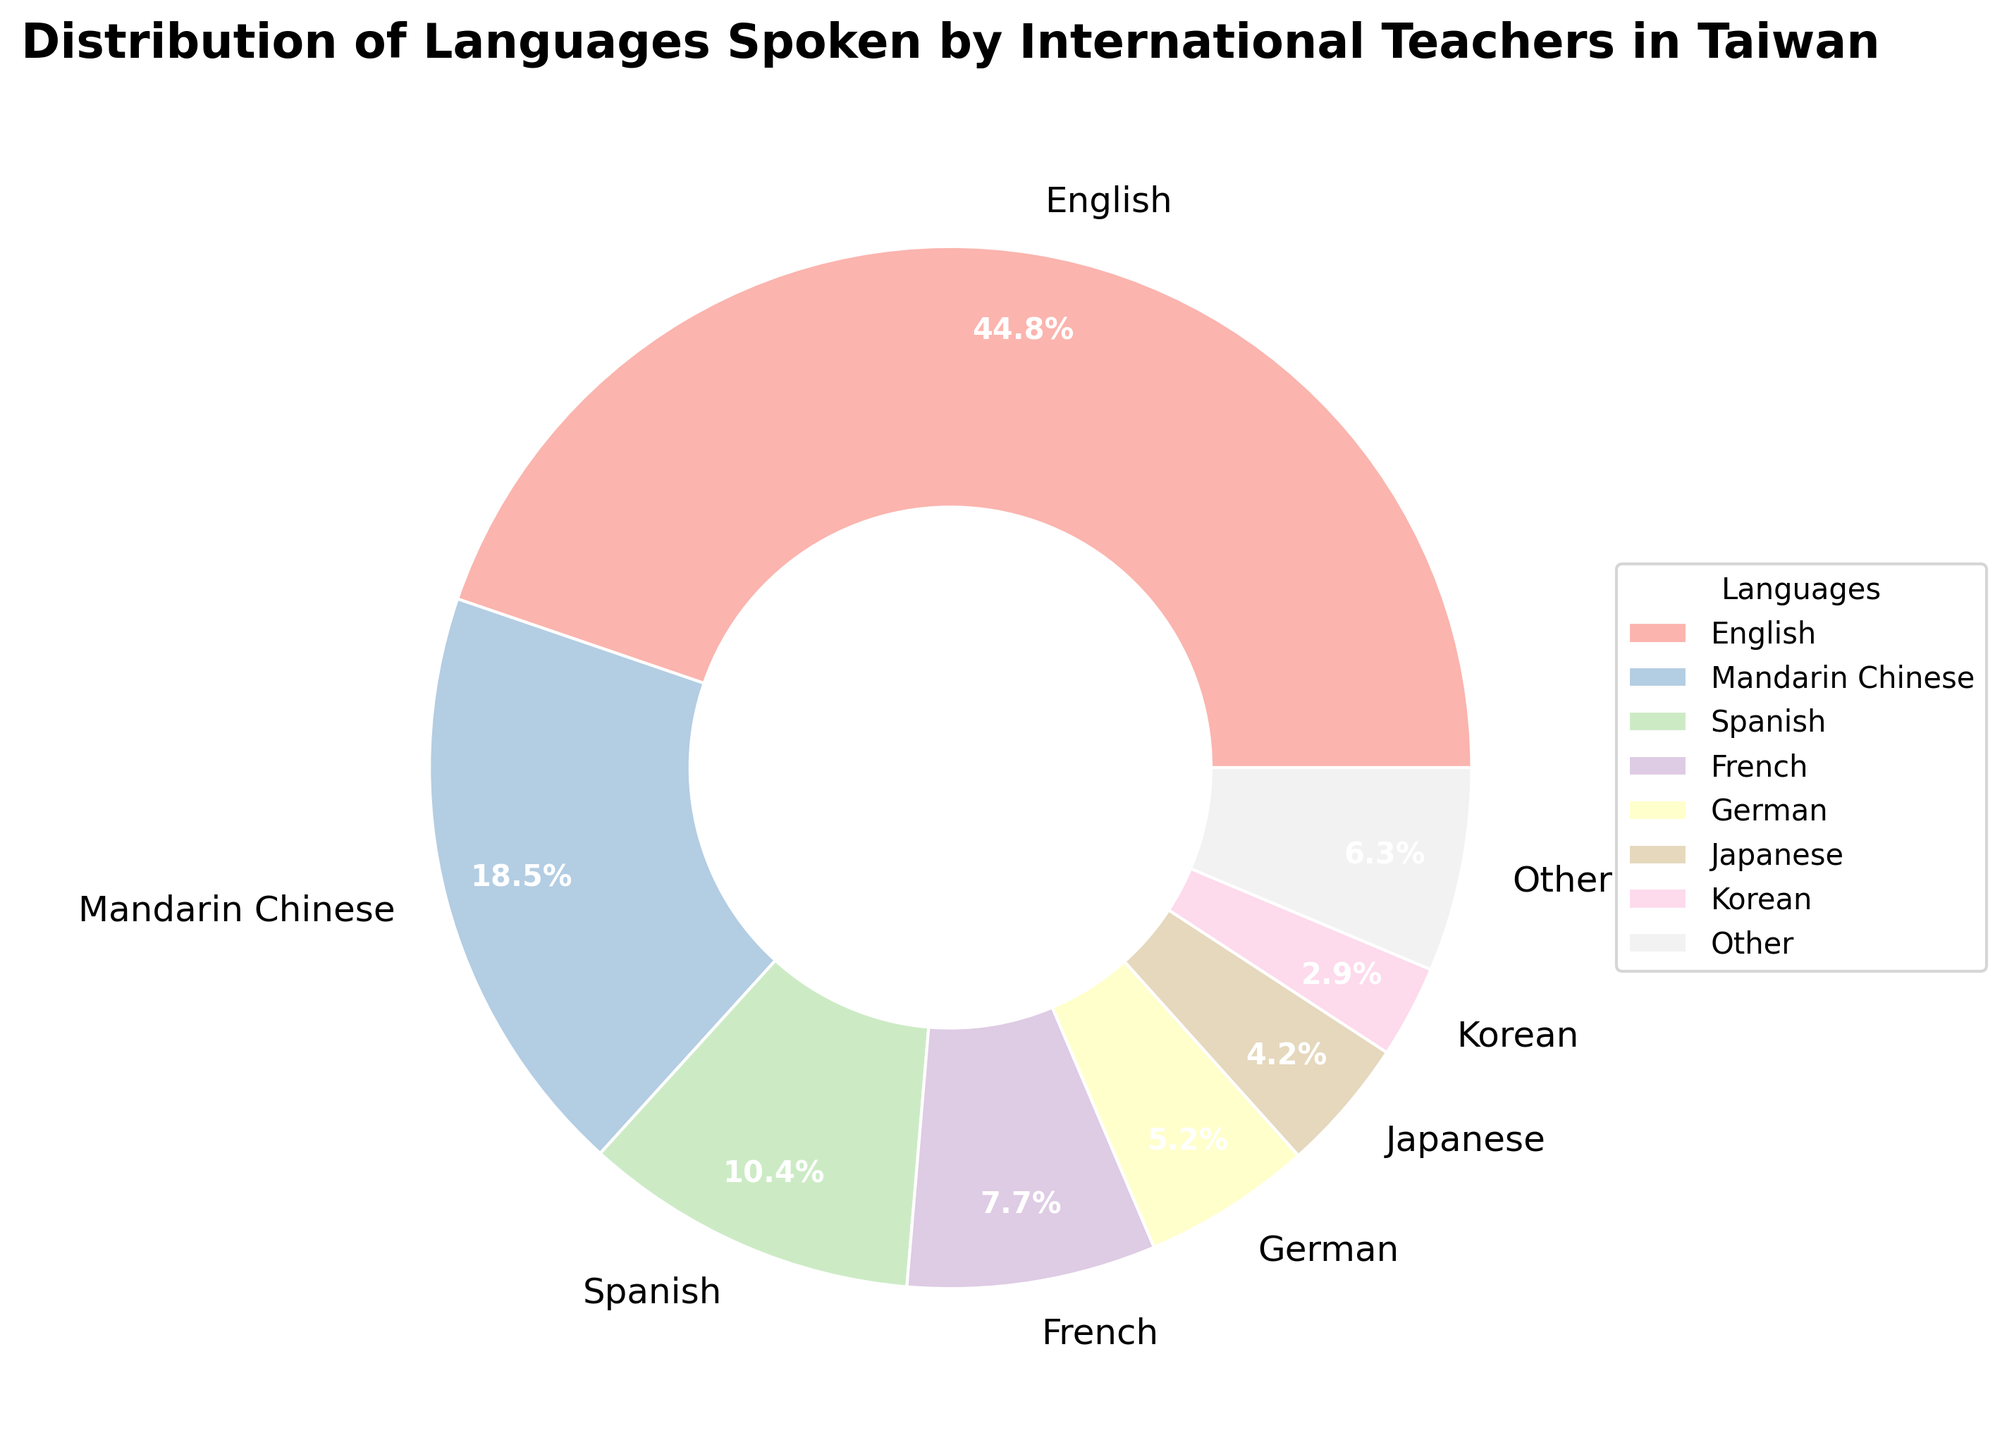What's the language spoken by the largest percentage of international teachers? By looking at the pie chart, the segment with the highest percentage is labeled "English", indicating that it is spoken by the largest percentage of international teachers.
Answer: English What's the difference in percentage between Mandarin Chinese speakers and Spanish speakers? From the chart, Mandarin Chinese speakers represent 18.7% and Spanish speakers represent 10.5%. The difference is found by subtracting these values: 18.7% - 10.5% = 8.2%.
Answer: 8.2% What is the combined percentage of teachers who speak French, German, and Japanese? According to the pie chart, the percentages for French, German, and Japanese are 7.8%, 5.3%, and 4.2% respectively. Summing these values gives: 7.8% + 5.3% + 4.2% = 17.3%.
Answer: 17.3% Compared to the languages categorized as "Other", is the percentage of Mandarin Chinese speakers higher or lower? The pie chart includes a segment labeled "Other" which is a combination of languages with individual percentages below the threshold. Since "Other" contains a percentage lower than 2.0%, and Mandarin Chinese is 18.7%, Mandarin Chinese's percentage is higher.
Answer: Higher Which language group is represented by the lightest color in the pie chart? By observing the visual coloring of the segments, the lightest color is usually associated with "Other" categories or smaller groups. Here, the "Other" category, which includes grouped smaller languages, is represented by the lightest color.
Answer: Other How many languages are categorized under 'Other'? Observing the pie chart and the data provided, languages with percentages below the threshold (2.0%) are grouped under "Other". These languages are Russian, Italian, Dutch, Portuguese, Hindi, and Arabic, making a total of 6 languages.
Answer: 6 Which two language groups have the closest percentages, and what are their percentages? From the chart, Japanese and Korean have the closest percentages, which are 4.2% and 2.9% respectively.
Answer: Japanese (4.2%) and Korean (2.9%) What is the sum of percentages of all languages that are explicitly labeled in the pie chart, excluding "Other"? To find this, sum all explicitly labeled languages' percentages: English 45.2%, Mandarin Chinese 18.7%, Spanish 10.5%, French 7.8%, German 5.3%, Japanese 4.2%, Korean 2.9%. Adding these gives: 45.2% + 18.7% + 10.5% + 7.8% + 5.3% + 4.2% + 2.9% = 94.6%.
Answer: 94.6% Which language has nearly half the percentage of French speakers? Observing the data, French is 7.8%. Nearly half of 7.8% is approximately 3.9%. Looking at the pie chart, Japanese at 4.2% is closest to this value.
Answer: Japanese What percentage of the language spoken by international teachers is not categorized as “Other”? To find this, subtract the percentage of "Other" from 100%. "Other" includes languages below the 2.0% threshold. Adding these: Russian (1.8%), Italian (1.5%), Dutch (1.1%), Portuguese (0.8%), Hindi (0.7%), Arabic (0.5%) = 6.4%. 100% - 6.4% = 93.6%.
Answer: 93.6% 